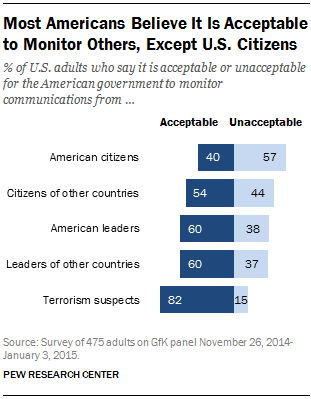List a handful of essential elements in this visual. What is considered an acceptable value for American citizens, 0.4? The product of the value and median of all "Unacceptable" bars for terrorism suspects is 570. 